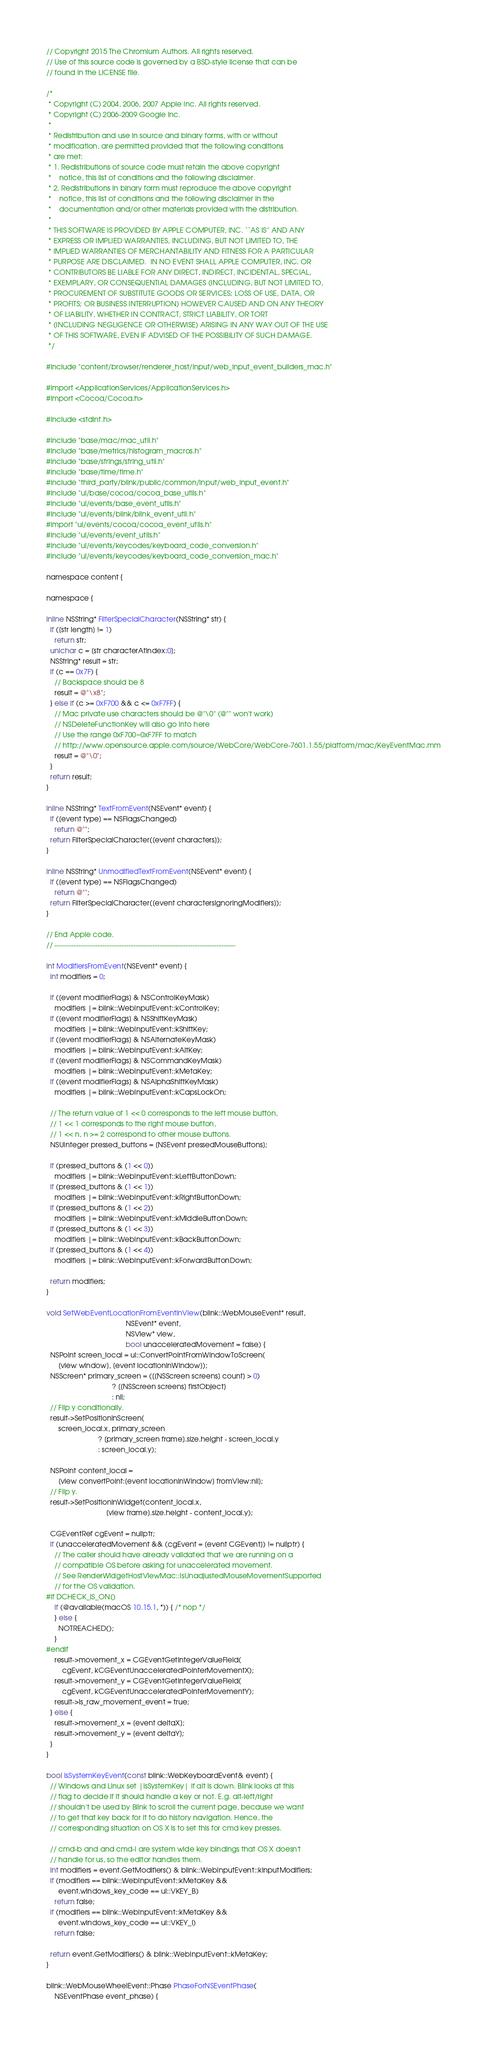Convert code to text. <code><loc_0><loc_0><loc_500><loc_500><_ObjectiveC_>// Copyright 2015 The Chromium Authors. All rights reserved.
// Use of this source code is governed by a BSD-style license that can be
// found in the LICENSE file.

/*
 * Copyright (C) 2004, 2006, 2007 Apple Inc. All rights reserved.
 * Copyright (C) 2006-2009 Google Inc.
 *
 * Redistribution and use in source and binary forms, with or without
 * modification, are permitted provided that the following conditions
 * are met:
 * 1. Redistributions of source code must retain the above copyright
 *    notice, this list of conditions and the following disclaimer.
 * 2. Redistributions in binary form must reproduce the above copyright
 *    notice, this list of conditions and the following disclaimer in the
 *    documentation and/or other materials provided with the distribution.
 *
 * THIS SOFTWARE IS PROVIDED BY APPLE COMPUTER, INC. ``AS IS'' AND ANY
 * EXPRESS OR IMPLIED WARRANTIES, INCLUDING, BUT NOT LIMITED TO, THE
 * IMPLIED WARRANTIES OF MERCHANTABILITY AND FITNESS FOR A PARTICULAR
 * PURPOSE ARE DISCLAIMED.  IN NO EVENT SHALL APPLE COMPUTER, INC. OR
 * CONTRIBUTORS BE LIABLE FOR ANY DIRECT, INDIRECT, INCIDENTAL, SPECIAL,
 * EXEMPLARY, OR CONSEQUENTIAL DAMAGES (INCLUDING, BUT NOT LIMITED TO,
 * PROCUREMENT OF SUBSTITUTE GOODS OR SERVICES; LOSS OF USE, DATA, OR
 * PROFITS; OR BUSINESS INTERRUPTION) HOWEVER CAUSED AND ON ANY THEORY
 * OF LIABILITY, WHETHER IN CONTRACT, STRICT LIABILITY, OR TORT
 * (INCLUDING NEGLIGENCE OR OTHERWISE) ARISING IN ANY WAY OUT OF THE USE
 * OF THIS SOFTWARE, EVEN IF ADVISED OF THE POSSIBILITY OF SUCH DAMAGE.
 */

#include "content/browser/renderer_host/input/web_input_event_builders_mac.h"

#import <ApplicationServices/ApplicationServices.h>
#import <Cocoa/Cocoa.h>

#include <stdint.h>

#include "base/mac/mac_util.h"
#include "base/metrics/histogram_macros.h"
#include "base/strings/string_util.h"
#include "base/time/time.h"
#include "third_party/blink/public/common/input/web_input_event.h"
#include "ui/base/cocoa/cocoa_base_utils.h"
#include "ui/events/base_event_utils.h"
#include "ui/events/blink/blink_event_util.h"
#import "ui/events/cocoa/cocoa_event_utils.h"
#include "ui/events/event_utils.h"
#include "ui/events/keycodes/keyboard_code_conversion.h"
#include "ui/events/keycodes/keyboard_code_conversion_mac.h"

namespace content {

namespace {

inline NSString* FilterSpecialCharacter(NSString* str) {
  if ([str length] != 1)
    return str;
  unichar c = [str characterAtIndex:0];
  NSString* result = str;
  if (c == 0x7F) {
    // Backspace should be 8
    result = @"\x8";
  } else if (c >= 0xF700 && c <= 0xF7FF) {
    // Mac private use characters should be @"\0" (@"" won't work)
    // NSDeleteFunctionKey will also go into here
    // Use the range 0xF700~0xF7FF to match
    // http://www.opensource.apple.com/source/WebCore/WebCore-7601.1.55/platform/mac/KeyEventMac.mm
    result = @"\0";
  }
  return result;
}

inline NSString* TextFromEvent(NSEvent* event) {
  if ([event type] == NSFlagsChanged)
    return @"";
  return FilterSpecialCharacter([event characters]);
}

inline NSString* UnmodifiedTextFromEvent(NSEvent* event) {
  if ([event type] == NSFlagsChanged)
    return @"";
  return FilterSpecialCharacter([event charactersIgnoringModifiers]);
}

// End Apple code.
// ----------------------------------------------------------------------------

int ModifiersFromEvent(NSEvent* event) {
  int modifiers = 0;

  if ([event modifierFlags] & NSControlKeyMask)
    modifiers |= blink::WebInputEvent::kControlKey;
  if ([event modifierFlags] & NSShiftKeyMask)
    modifiers |= blink::WebInputEvent::kShiftKey;
  if ([event modifierFlags] & NSAlternateKeyMask)
    modifiers |= blink::WebInputEvent::kAltKey;
  if ([event modifierFlags] & NSCommandKeyMask)
    modifiers |= blink::WebInputEvent::kMetaKey;
  if ([event modifierFlags] & NSAlphaShiftKeyMask)
    modifiers |= blink::WebInputEvent::kCapsLockOn;

  // The return value of 1 << 0 corresponds to the left mouse button,
  // 1 << 1 corresponds to the right mouse button,
  // 1 << n, n >= 2 correspond to other mouse buttons.
  NSUInteger pressed_buttons = [NSEvent pressedMouseButtons];

  if (pressed_buttons & (1 << 0))
    modifiers |= blink::WebInputEvent::kLeftButtonDown;
  if (pressed_buttons & (1 << 1))
    modifiers |= blink::WebInputEvent::kRightButtonDown;
  if (pressed_buttons & (1 << 2))
    modifiers |= blink::WebInputEvent::kMiddleButtonDown;
  if (pressed_buttons & (1 << 3))
    modifiers |= blink::WebInputEvent::kBackButtonDown;
  if (pressed_buttons & (1 << 4))
    modifiers |= blink::WebInputEvent::kForwardButtonDown;

  return modifiers;
}

void SetWebEventLocationFromEventInView(blink::WebMouseEvent* result,
                                        NSEvent* event,
                                        NSView* view,
                                        bool unacceleratedMovement = false) {
  NSPoint screen_local = ui::ConvertPointFromWindowToScreen(
      [view window], [event locationInWindow]);
  NSScreen* primary_screen = ([[NSScreen screens] count] > 0)
                                 ? [[NSScreen screens] firstObject]
                                 : nil;
  // Flip y conditionally.
  result->SetPositionInScreen(
      screen_local.x, primary_screen
                          ? [primary_screen frame].size.height - screen_local.y
                          : screen_local.y);

  NSPoint content_local =
      [view convertPoint:[event locationInWindow] fromView:nil];
  // Flip y.
  result->SetPositionInWidget(content_local.x,
                              [view frame].size.height - content_local.y);

  CGEventRef cgEvent = nullptr;
  if (unacceleratedMovement && (cgEvent = [event CGEvent]) != nullptr) {
    // The caller should have already validated that we are running on a
    // compatible OS before asking for unaccelerated movement.
    // See RenderWidgetHostViewMac::IsUnadjustedMouseMovementSupported
    // for the OS validation.
#if DCHECK_IS_ON()
    if (@available(macOS 10.15.1, *)) { /* nop */
    } else {
      NOTREACHED();
    }
#endif
    result->movement_x = CGEventGetIntegerValueField(
        cgEvent, kCGEventUnacceleratedPointerMovementX);
    result->movement_y = CGEventGetIntegerValueField(
        cgEvent, kCGEventUnacceleratedPointerMovementY);
    result->is_raw_movement_event = true;
  } else {
    result->movement_x = [event deltaX];
    result->movement_y = [event deltaY];
  }
}

bool IsSystemKeyEvent(const blink::WebKeyboardEvent& event) {
  // Windows and Linux set |isSystemKey| if alt is down. Blink looks at this
  // flag to decide if it should handle a key or not. E.g. alt-left/right
  // shouldn't be used by Blink to scroll the current page, because we want
  // to get that key back for it to do history navigation. Hence, the
  // corresponding situation on OS X is to set this for cmd key presses.

  // cmd-b and and cmd-i are system wide key bindings that OS X doesn't
  // handle for us, so the editor handles them.
  int modifiers = event.GetModifiers() & blink::WebInputEvent::kInputModifiers;
  if (modifiers == blink::WebInputEvent::kMetaKey &&
      event.windows_key_code == ui::VKEY_B)
    return false;
  if (modifiers == blink::WebInputEvent::kMetaKey &&
      event.windows_key_code == ui::VKEY_I)
    return false;

  return event.GetModifiers() & blink::WebInputEvent::kMetaKey;
}

blink::WebMouseWheelEvent::Phase PhaseForNSEventPhase(
    NSEventPhase event_phase) {</code> 